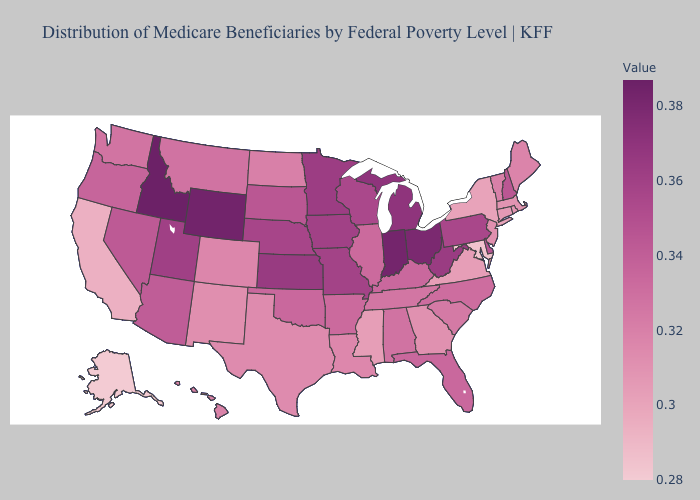Does Alaska have the lowest value in the USA?
Quick response, please. Yes. Does South Dakota have a lower value than California?
Keep it brief. No. Does South Dakota have a lower value than Alabama?
Give a very brief answer. No. Among the states that border Oklahoma , which have the lowest value?
Be succinct. New Mexico. Does Alabama have the lowest value in the USA?
Be succinct. No. Which states have the highest value in the USA?
Keep it brief. Idaho. Which states hav the highest value in the West?
Quick response, please. Idaho. Which states have the lowest value in the USA?
Write a very short answer. Alaska. 